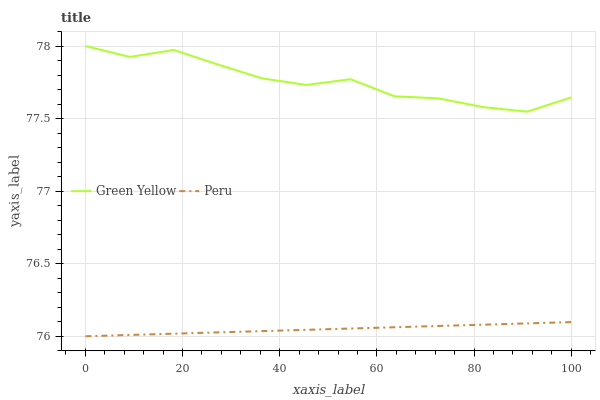Does Peru have the minimum area under the curve?
Answer yes or no. Yes. Does Green Yellow have the maximum area under the curve?
Answer yes or no. Yes. Does Peru have the maximum area under the curve?
Answer yes or no. No. Is Peru the smoothest?
Answer yes or no. Yes. Is Green Yellow the roughest?
Answer yes or no. Yes. Is Peru the roughest?
Answer yes or no. No. Does Peru have the lowest value?
Answer yes or no. Yes. Does Green Yellow have the highest value?
Answer yes or no. Yes. Does Peru have the highest value?
Answer yes or no. No. Is Peru less than Green Yellow?
Answer yes or no. Yes. Is Green Yellow greater than Peru?
Answer yes or no. Yes. Does Peru intersect Green Yellow?
Answer yes or no. No. 